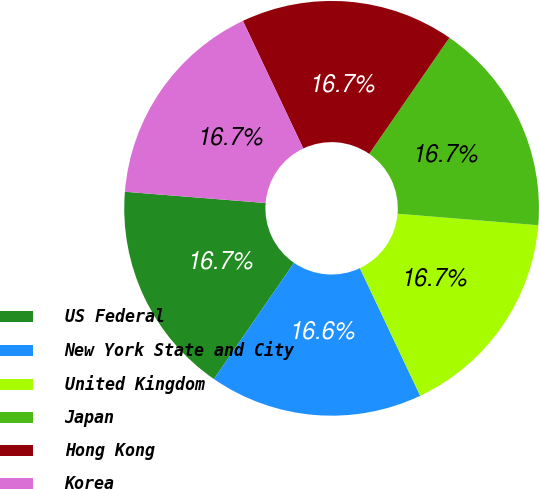Convert chart to OTSL. <chart><loc_0><loc_0><loc_500><loc_500><pie_chart><fcel>US Federal<fcel>New York State and City<fcel>United Kingdom<fcel>Japan<fcel>Hong Kong<fcel>Korea<nl><fcel>16.67%<fcel>16.63%<fcel>16.67%<fcel>16.68%<fcel>16.65%<fcel>16.69%<nl></chart> 